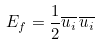<formula> <loc_0><loc_0><loc_500><loc_500>E _ { f } = { \frac { 1 } { 2 } } { \overline { { u _ { i } } } } \, { \overline { { u _ { i } } } }</formula> 